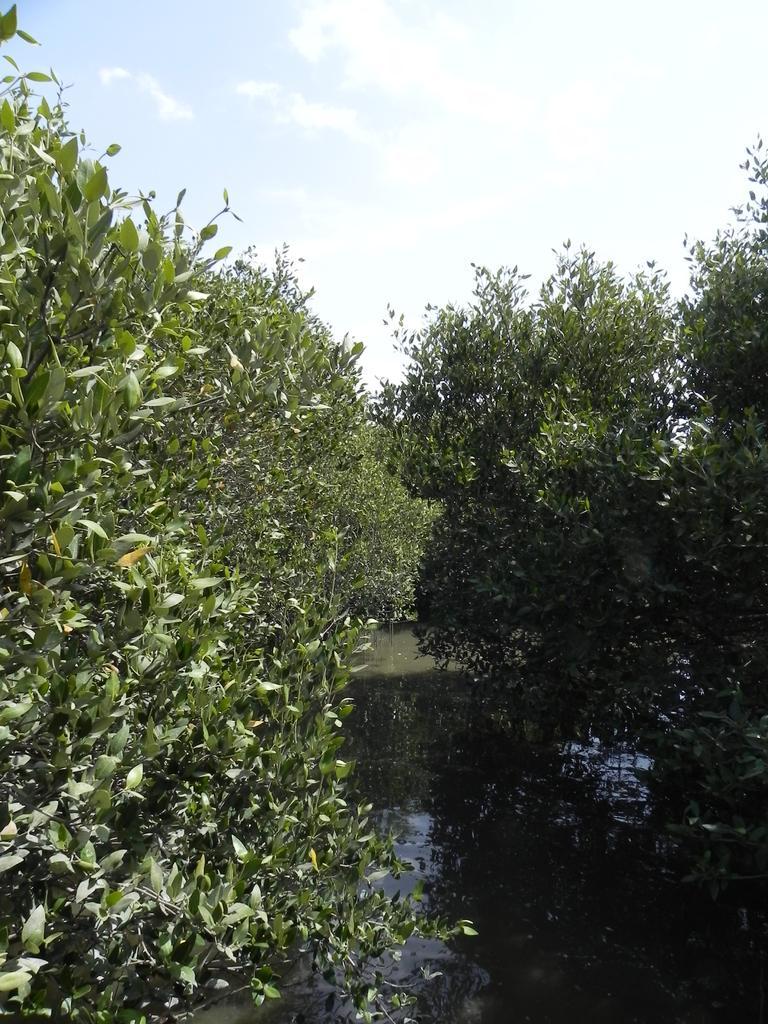How would you summarize this image in a sentence or two? In this picture, I can see a small lake and certain trees and sky. 